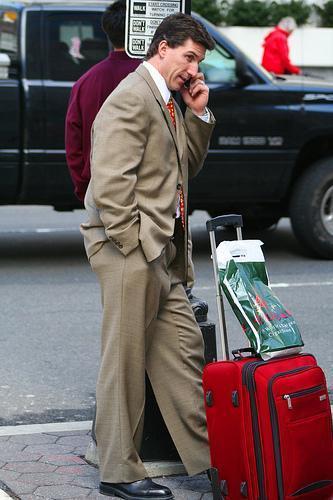How many vehicles are shown?
Give a very brief answer. 1. 